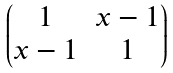<formula> <loc_0><loc_0><loc_500><loc_500>\begin{pmatrix} 1 & x - 1 \\ x - 1 & 1 \end{pmatrix}</formula> 